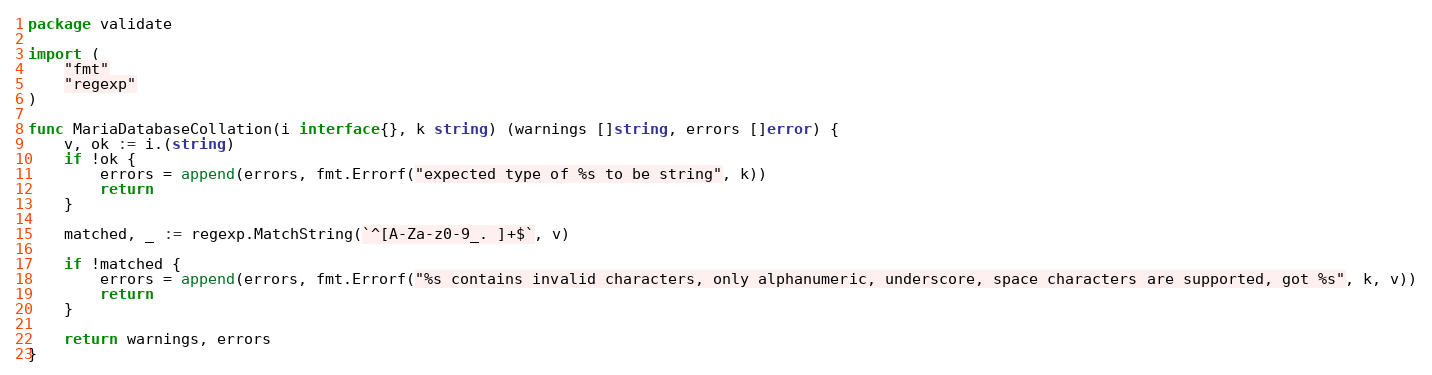Convert code to text. <code><loc_0><loc_0><loc_500><loc_500><_Go_>package validate

import (
	"fmt"
	"regexp"
)

func MariaDatabaseCollation(i interface{}, k string) (warnings []string, errors []error) {
	v, ok := i.(string)
	if !ok {
		errors = append(errors, fmt.Errorf("expected type of %s to be string", k))
		return
	}

	matched, _ := regexp.MatchString(`^[A-Za-z0-9_. ]+$`, v)

	if !matched {
		errors = append(errors, fmt.Errorf("%s contains invalid characters, only alphanumeric, underscore, space characters are supported, got %s", k, v))
		return
	}

	return warnings, errors
}
</code> 